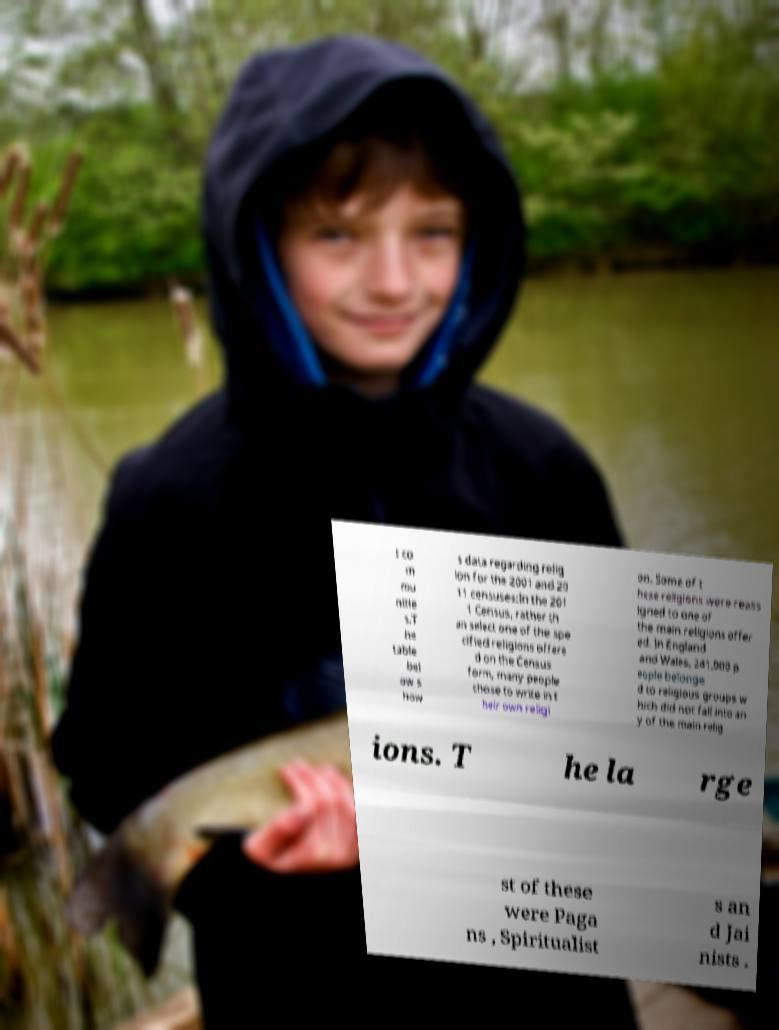Could you extract and type out the text from this image? t co m mu nitie s.T he table bel ow s how s data regarding relig ion for the 2001 and 20 11 censuses:In the 201 1 Census, rather th an select one of the spe cified religions offere d on the Census form, many people chose to write in t heir own religi on. Some of t hese religions were reass igned to one of the main religions offer ed. In England and Wales, 241,000 p eople belonge d to religious groups w hich did not fall into an y of the main relig ions. T he la rge st of these were Paga ns , Spiritualist s an d Jai nists . 